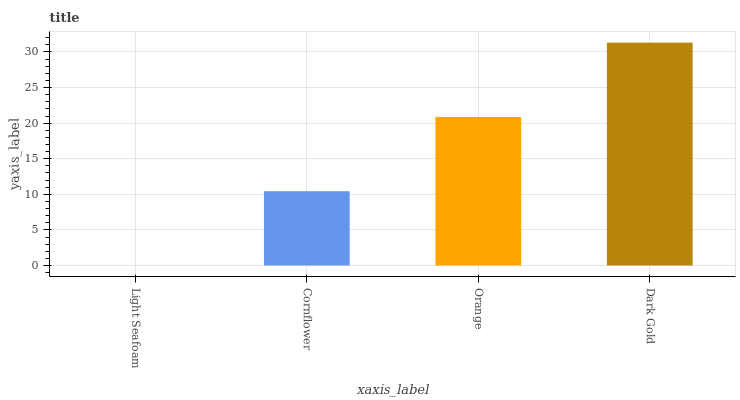Is Light Seafoam the minimum?
Answer yes or no. Yes. Is Dark Gold the maximum?
Answer yes or no. Yes. Is Cornflower the minimum?
Answer yes or no. No. Is Cornflower the maximum?
Answer yes or no. No. Is Cornflower greater than Light Seafoam?
Answer yes or no. Yes. Is Light Seafoam less than Cornflower?
Answer yes or no. Yes. Is Light Seafoam greater than Cornflower?
Answer yes or no. No. Is Cornflower less than Light Seafoam?
Answer yes or no. No. Is Orange the high median?
Answer yes or no. Yes. Is Cornflower the low median?
Answer yes or no. Yes. Is Dark Gold the high median?
Answer yes or no. No. Is Light Seafoam the low median?
Answer yes or no. No. 